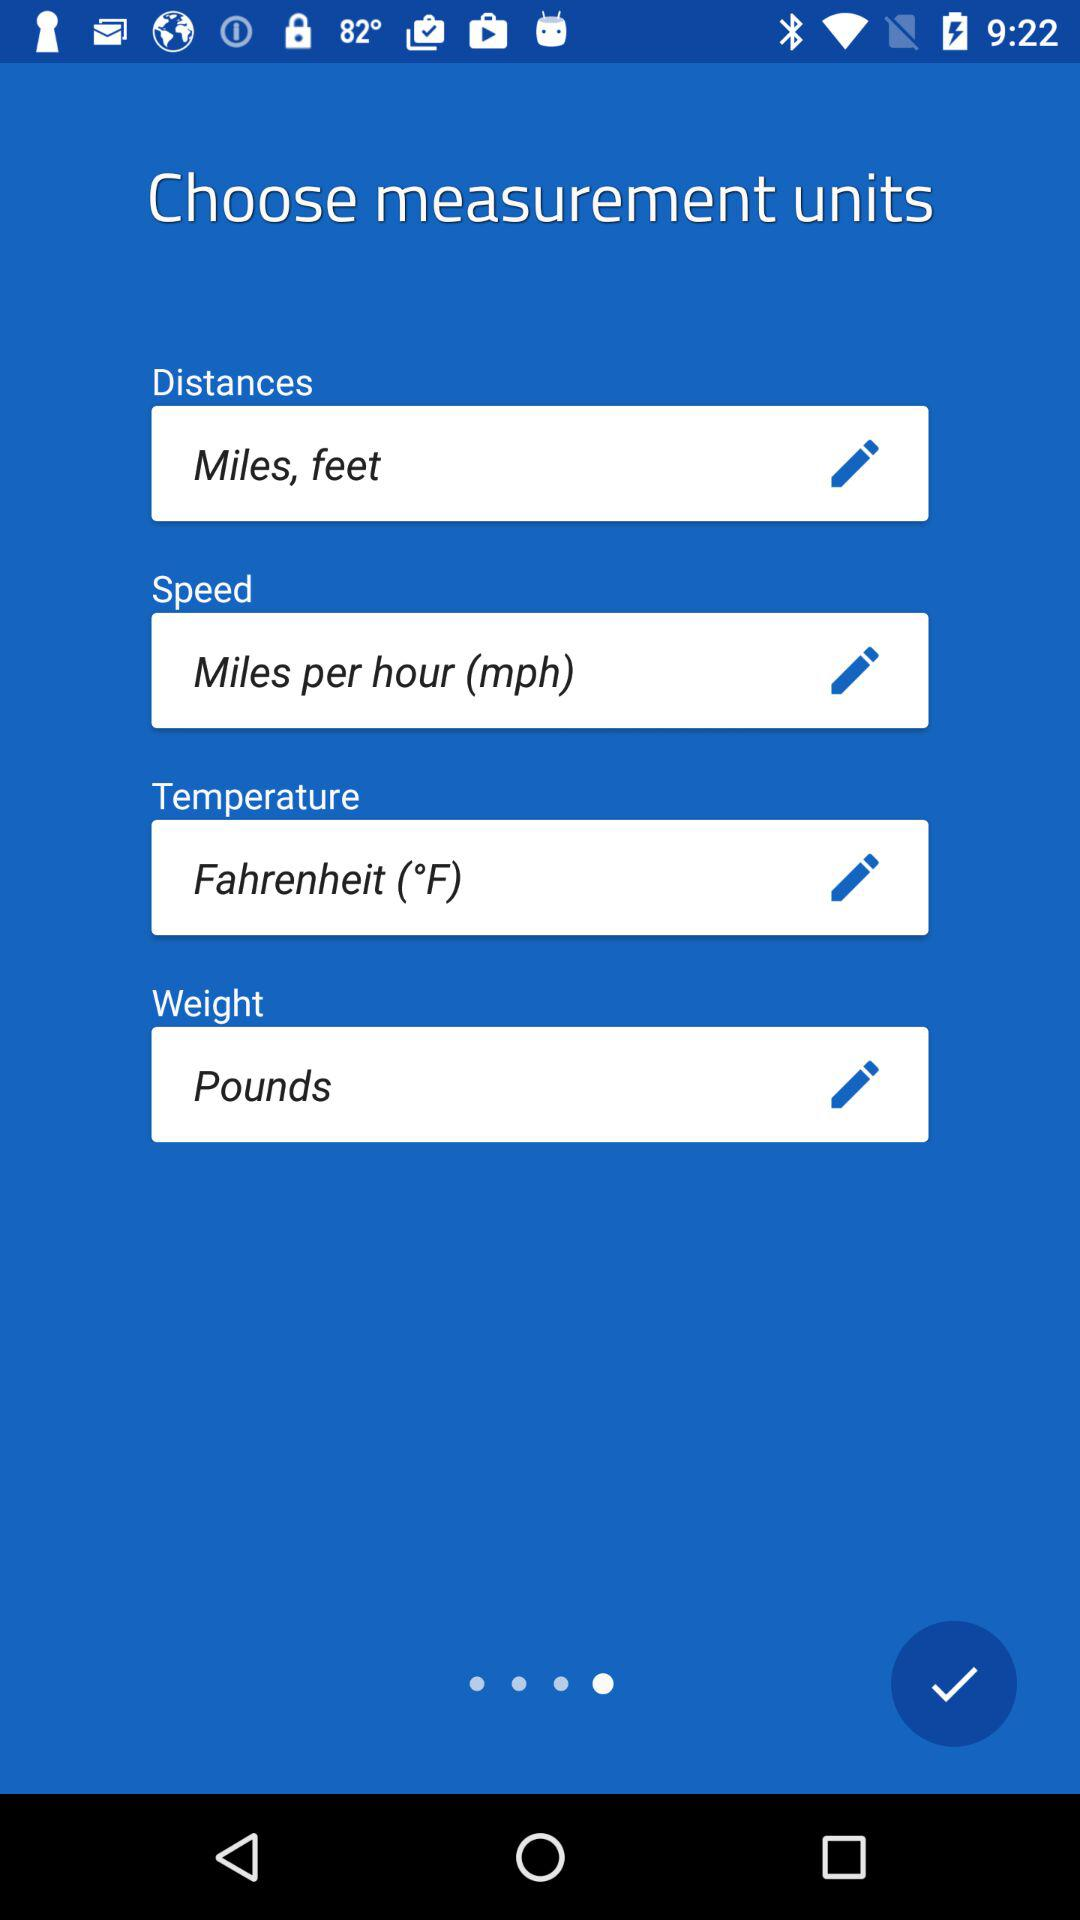What is the unit of weight? The unit of weight is pounds. 